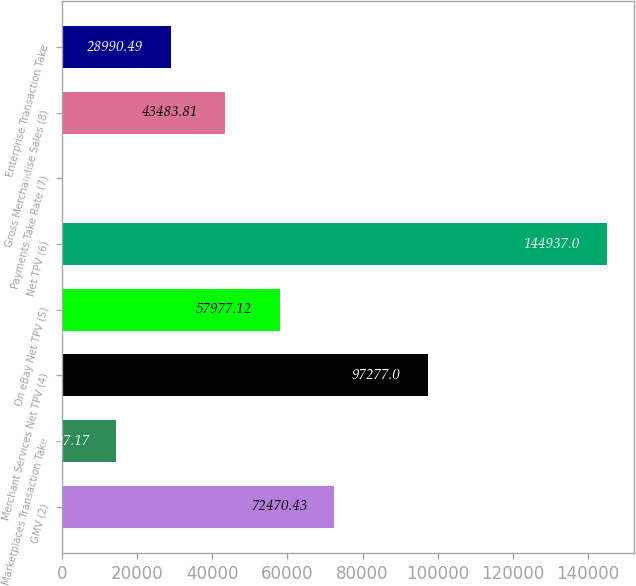Convert chart to OTSL. <chart><loc_0><loc_0><loc_500><loc_500><bar_chart><fcel>GMV (2)<fcel>Marketplaces Transaction Take<fcel>Merchant Services Net TPV (4)<fcel>On eBay Net TPV (5)<fcel>Net TPV (6)<fcel>Payments Take Rate (7)<fcel>Gross Merchandise Sales (8)<fcel>Enterprise Transaction Take<nl><fcel>72470.4<fcel>14497.2<fcel>97277<fcel>57977.1<fcel>144937<fcel>3.85<fcel>43483.8<fcel>28990.5<nl></chart> 